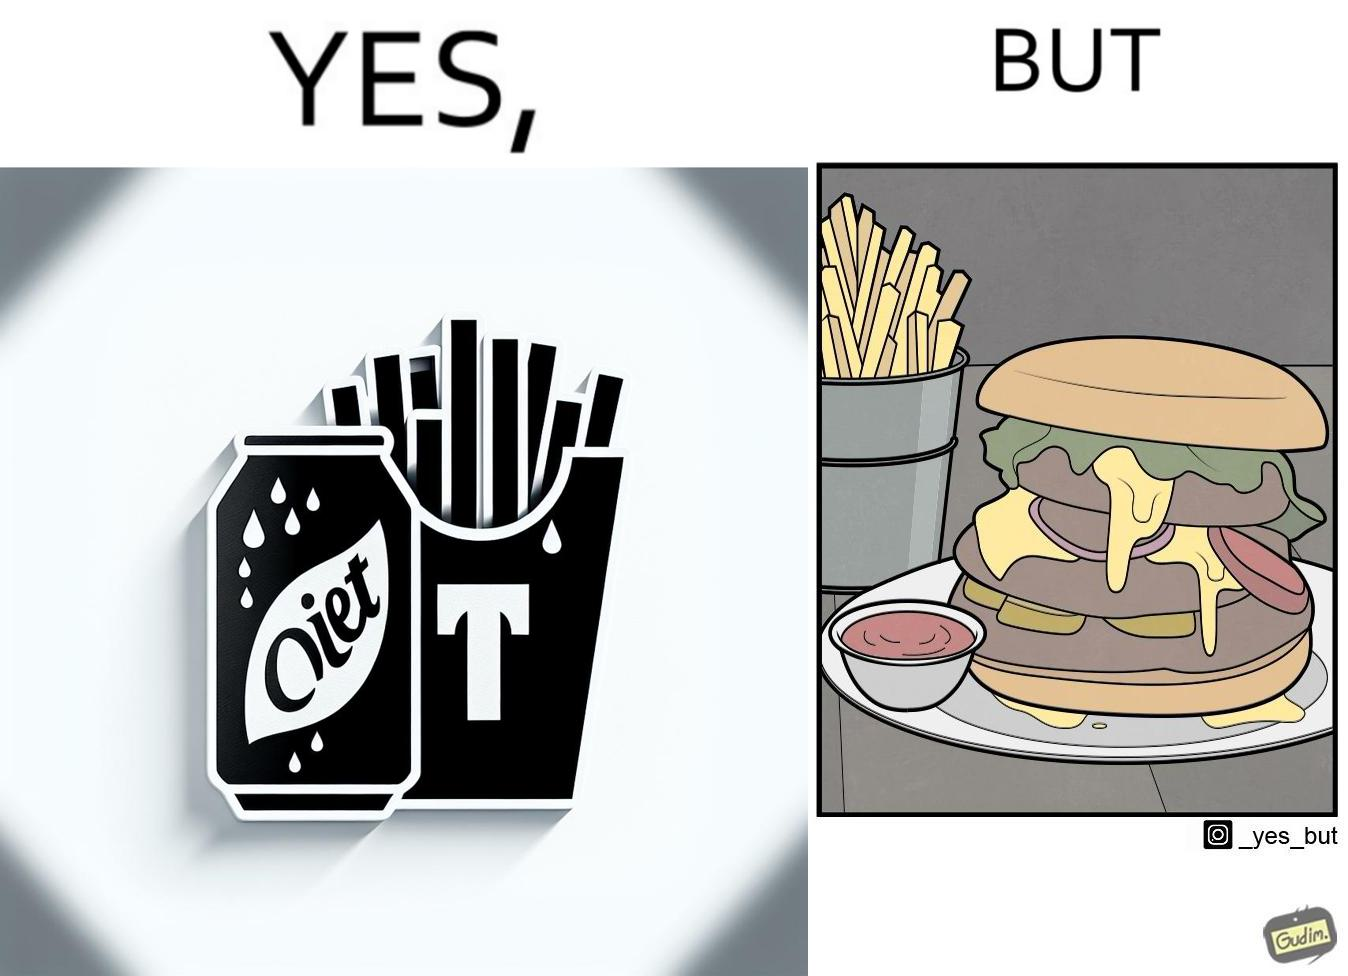What is shown in the left half versus the right half of this image? In the left part of the image: a cold drink can, named by diet cola, with french fries at the back In the right part of the image: a huge size burger with french fries 